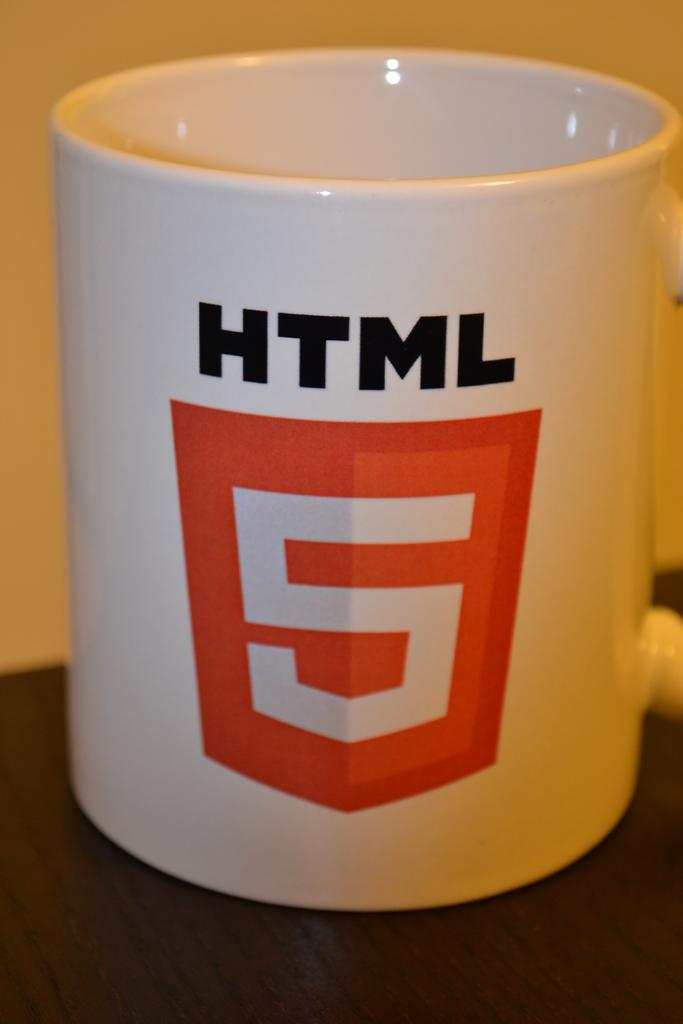What is the color of the cup in the image? The cup in the image is white. Is there any text or design on the cup? Yes, something is written on the cup. What colors are used for the writing on the cup? The writing on the cup is in black and red colors. What is the color of the background in the image? The background of the image is in cream color. Can you see the seashore in the background of the image? No, the seashore is not present in the image; the background is in cream color. 